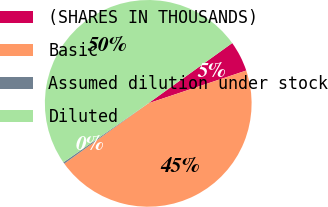Convert chart. <chart><loc_0><loc_0><loc_500><loc_500><pie_chart><fcel>(SHARES IN THOUSANDS)<fcel>Basic<fcel>Assumed dilution under stock<fcel>Diluted<nl><fcel>4.77%<fcel>45.23%<fcel>0.25%<fcel>49.75%<nl></chart> 